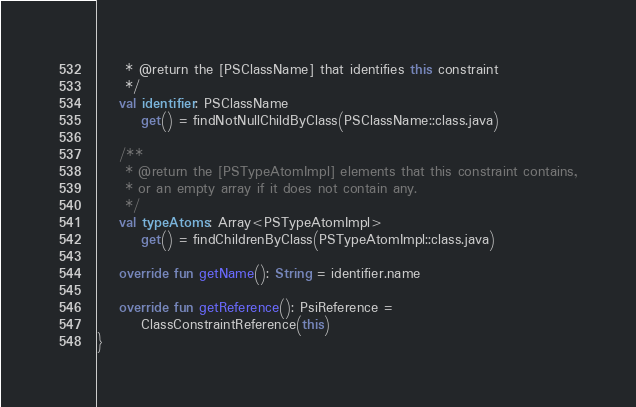<code> <loc_0><loc_0><loc_500><loc_500><_Kotlin_>     * @return the [PSClassName] that identifies this constraint
     */
    val identifier: PSClassName
        get() = findNotNullChildByClass(PSClassName::class.java)

    /**
     * @return the [PSTypeAtomImpl] elements that this constraint contains,
     * or an empty array if it does not contain any.
     */
    val typeAtoms: Array<PSTypeAtomImpl>
        get() = findChildrenByClass(PSTypeAtomImpl::class.java)

    override fun getName(): String = identifier.name

    override fun getReference(): PsiReference =
        ClassConstraintReference(this)
}
</code> 